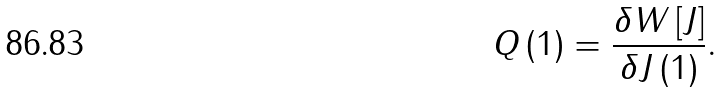<formula> <loc_0><loc_0><loc_500><loc_500>Q \left ( 1 \right ) = \frac { \delta W \left [ J \right ] } { \delta J \left ( 1 \right ) } .</formula> 